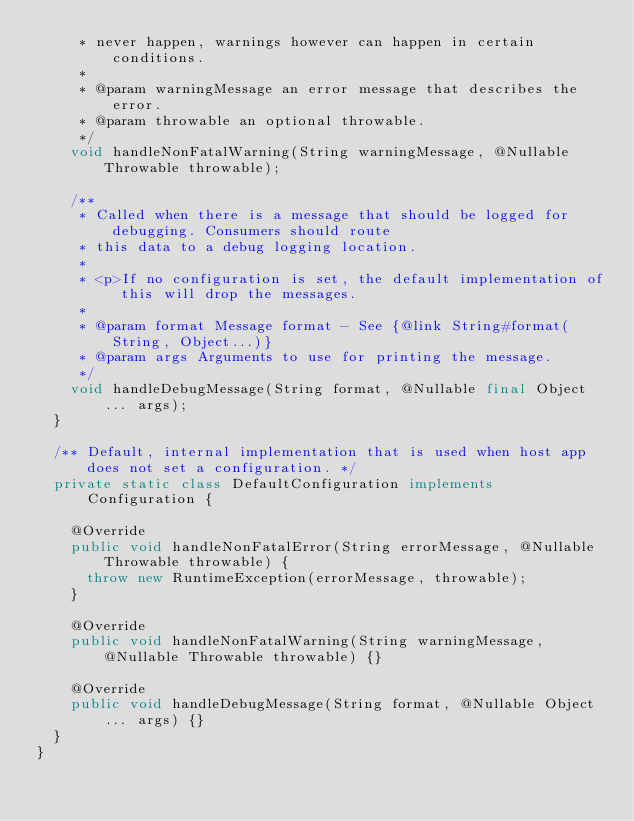<code> <loc_0><loc_0><loc_500><loc_500><_Java_>     * never happen, warnings however can happen in certain conditions.
     *
     * @param warningMessage an error message that describes the error.
     * @param throwable an optional throwable.
     */
    void handleNonFatalWarning(String warningMessage, @Nullable Throwable throwable);

    /**
     * Called when there is a message that should be logged for debugging. Consumers should route
     * this data to a debug logging location.
     *
     * <p>If no configuration is set, the default implementation of this will drop the messages.
     *
     * @param format Message format - See {@link String#format(String, Object...)}
     * @param args Arguments to use for printing the message.
     */
    void handleDebugMessage(String format, @Nullable final Object... args);
  }

  /** Default, internal implementation that is used when host app does not set a configuration. */
  private static class DefaultConfiguration implements Configuration {

    @Override
    public void handleNonFatalError(String errorMessage, @Nullable Throwable throwable) {
      throw new RuntimeException(errorMessage, throwable);
    }

    @Override
    public void handleNonFatalWarning(String warningMessage, @Nullable Throwable throwable) {}

    @Override
    public void handleDebugMessage(String format, @Nullable Object... args) {}
  }
}
</code> 